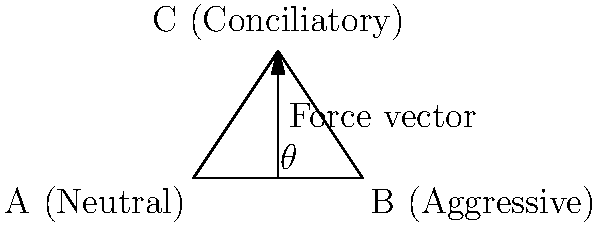In a group conflict resolution scenario, three individuals are positioned as shown in the diagram. Person A maintains a neutral stance, B displays aggressive body language, and C adopts a conciliatory posture. If C exerts a force to mediate between A and B, what angle $\theta$ should C's gesture make with the horizontal to maximize its effectiveness in bringing A and B closer together? To determine the optimal angle for C's mediating gesture, we need to consider the biomechanics of the situation:

1. The triangle represents the spatial arrangement of the three individuals.
2. The force vector from C represents the mediating gesture or movement.
3. To maximize effectiveness, we want to minimize the distance between A and B while maintaining C's position.

Step 1: Recognize that the optimal force vector should be perpendicular to line AB.
Step 2: In a right triangle, the angle between the hypotenuse and the base is complementary to the angle between the height and the base.
Step 3: The triangle ABC is a right triangle with the right angle at C.
Step 4: The height of the triangle (from C to AB) bisects the base AB.
Step 5: In a 3-4-5 right triangle, the angle between the hypotenuse and the base is:
       $$\theta = \arctan(\frac{3}{4}) \approx 36.87°$$
Step 6: The complementary angle to this is:
       $$90° - 36.87° = 53.13°$$

Therefore, the optimal angle $\theta$ for C's mediating gesture is approximately 53.13° from the horizontal.
Answer: 53.13° 